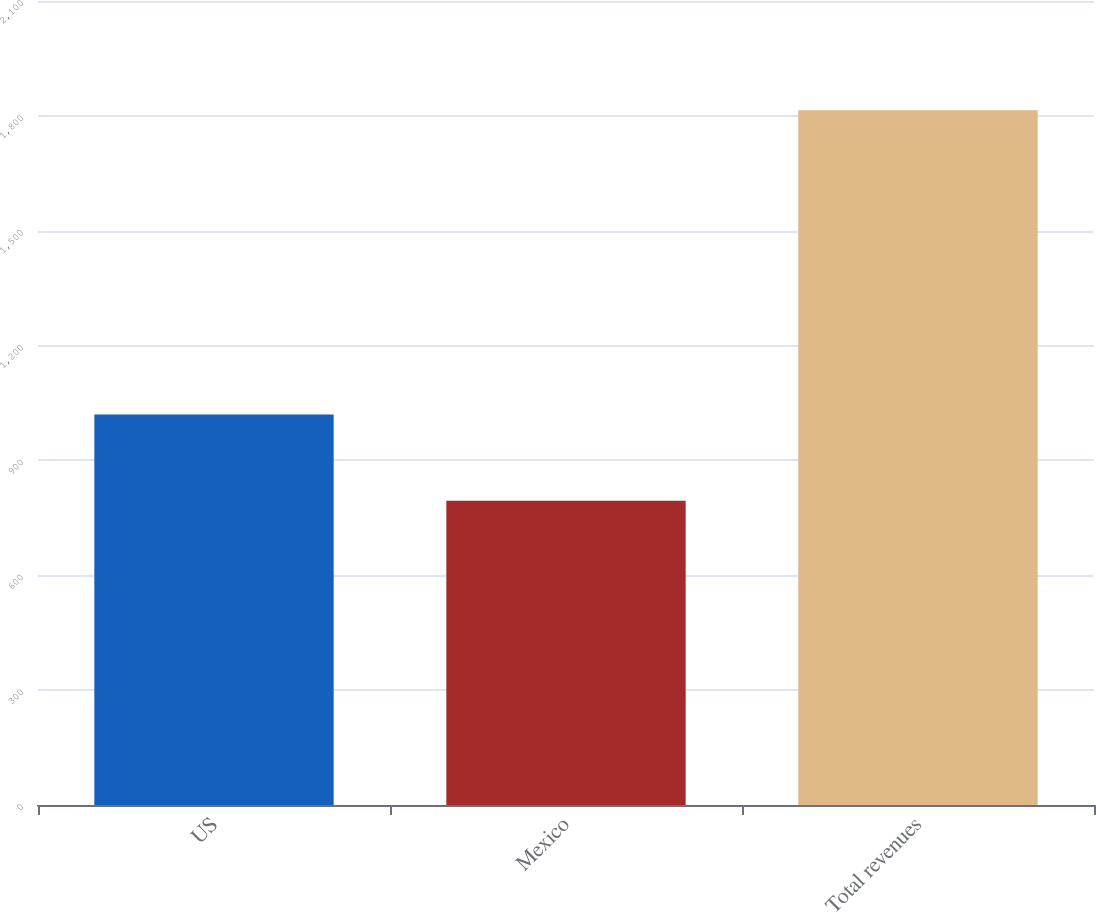Convert chart. <chart><loc_0><loc_0><loc_500><loc_500><bar_chart><fcel>US<fcel>Mexico<fcel>Total revenues<nl><fcel>1020.1<fcel>794.7<fcel>1814.8<nl></chart> 